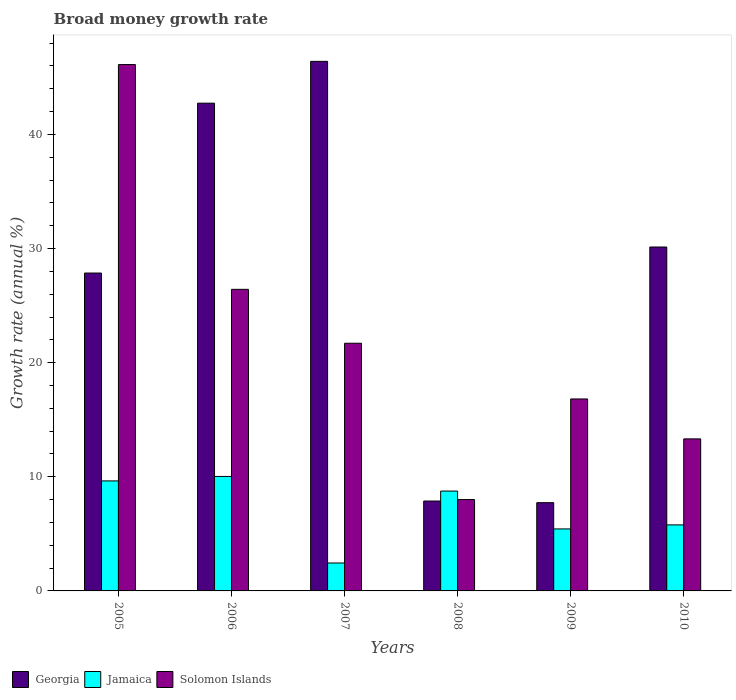Are the number of bars on each tick of the X-axis equal?
Provide a succinct answer. Yes. What is the label of the 5th group of bars from the left?
Your answer should be compact. 2009. In how many cases, is the number of bars for a given year not equal to the number of legend labels?
Provide a succinct answer. 0. What is the growth rate in Solomon Islands in 2006?
Give a very brief answer. 26.42. Across all years, what is the maximum growth rate in Georgia?
Offer a very short reply. 46.4. Across all years, what is the minimum growth rate in Georgia?
Keep it short and to the point. 7.73. In which year was the growth rate in Solomon Islands minimum?
Your answer should be compact. 2008. What is the total growth rate in Jamaica in the graph?
Your answer should be compact. 42.08. What is the difference between the growth rate in Georgia in 2007 and that in 2010?
Your response must be concise. 16.27. What is the difference between the growth rate in Solomon Islands in 2008 and the growth rate in Georgia in 2007?
Your response must be concise. -38.39. What is the average growth rate in Georgia per year?
Make the answer very short. 27.12. In the year 2006, what is the difference between the growth rate in Jamaica and growth rate in Georgia?
Your answer should be compact. -32.71. What is the ratio of the growth rate in Solomon Islands in 2009 to that in 2010?
Offer a terse response. 1.26. Is the difference between the growth rate in Jamaica in 2006 and 2010 greater than the difference between the growth rate in Georgia in 2006 and 2010?
Your response must be concise. No. What is the difference between the highest and the second highest growth rate in Solomon Islands?
Provide a succinct answer. 19.69. What is the difference between the highest and the lowest growth rate in Georgia?
Your answer should be very brief. 38.67. What does the 3rd bar from the left in 2006 represents?
Your answer should be very brief. Solomon Islands. What does the 2nd bar from the right in 2008 represents?
Your response must be concise. Jamaica. Is it the case that in every year, the sum of the growth rate in Georgia and growth rate in Solomon Islands is greater than the growth rate in Jamaica?
Your answer should be compact. Yes. Are the values on the major ticks of Y-axis written in scientific E-notation?
Ensure brevity in your answer.  No. Does the graph contain any zero values?
Offer a terse response. No. Does the graph contain grids?
Ensure brevity in your answer.  No. Where does the legend appear in the graph?
Make the answer very short. Bottom left. How many legend labels are there?
Your answer should be compact. 3. How are the legend labels stacked?
Keep it short and to the point. Horizontal. What is the title of the graph?
Offer a terse response. Broad money growth rate. What is the label or title of the X-axis?
Offer a very short reply. Years. What is the label or title of the Y-axis?
Provide a succinct answer. Growth rate (annual %). What is the Growth rate (annual %) of Georgia in 2005?
Ensure brevity in your answer.  27.85. What is the Growth rate (annual %) in Jamaica in 2005?
Provide a succinct answer. 9.64. What is the Growth rate (annual %) of Solomon Islands in 2005?
Keep it short and to the point. 46.12. What is the Growth rate (annual %) of Georgia in 2006?
Offer a terse response. 42.74. What is the Growth rate (annual %) of Jamaica in 2006?
Give a very brief answer. 10.03. What is the Growth rate (annual %) of Solomon Islands in 2006?
Provide a short and direct response. 26.42. What is the Growth rate (annual %) in Georgia in 2007?
Your answer should be compact. 46.4. What is the Growth rate (annual %) of Jamaica in 2007?
Keep it short and to the point. 2.45. What is the Growth rate (annual %) of Solomon Islands in 2007?
Your response must be concise. 21.7. What is the Growth rate (annual %) of Georgia in 2008?
Ensure brevity in your answer.  7.88. What is the Growth rate (annual %) of Jamaica in 2008?
Your answer should be compact. 8.75. What is the Growth rate (annual %) of Solomon Islands in 2008?
Ensure brevity in your answer.  8.01. What is the Growth rate (annual %) in Georgia in 2009?
Offer a terse response. 7.73. What is the Growth rate (annual %) in Jamaica in 2009?
Provide a succinct answer. 5.43. What is the Growth rate (annual %) of Solomon Islands in 2009?
Provide a succinct answer. 16.82. What is the Growth rate (annual %) in Georgia in 2010?
Ensure brevity in your answer.  30.13. What is the Growth rate (annual %) of Jamaica in 2010?
Keep it short and to the point. 5.79. What is the Growth rate (annual %) in Solomon Islands in 2010?
Keep it short and to the point. 13.32. Across all years, what is the maximum Growth rate (annual %) of Georgia?
Offer a terse response. 46.4. Across all years, what is the maximum Growth rate (annual %) of Jamaica?
Your answer should be very brief. 10.03. Across all years, what is the maximum Growth rate (annual %) in Solomon Islands?
Your response must be concise. 46.12. Across all years, what is the minimum Growth rate (annual %) of Georgia?
Ensure brevity in your answer.  7.73. Across all years, what is the minimum Growth rate (annual %) of Jamaica?
Offer a very short reply. 2.45. Across all years, what is the minimum Growth rate (annual %) in Solomon Islands?
Offer a very short reply. 8.01. What is the total Growth rate (annual %) of Georgia in the graph?
Keep it short and to the point. 162.73. What is the total Growth rate (annual %) of Jamaica in the graph?
Your response must be concise. 42.08. What is the total Growth rate (annual %) of Solomon Islands in the graph?
Offer a terse response. 132.39. What is the difference between the Growth rate (annual %) of Georgia in 2005 and that in 2006?
Ensure brevity in your answer.  -14.88. What is the difference between the Growth rate (annual %) in Jamaica in 2005 and that in 2006?
Offer a very short reply. -0.39. What is the difference between the Growth rate (annual %) in Solomon Islands in 2005 and that in 2006?
Offer a terse response. 19.69. What is the difference between the Growth rate (annual %) of Georgia in 2005 and that in 2007?
Offer a terse response. -18.55. What is the difference between the Growth rate (annual %) of Jamaica in 2005 and that in 2007?
Your response must be concise. 7.19. What is the difference between the Growth rate (annual %) in Solomon Islands in 2005 and that in 2007?
Your answer should be compact. 24.42. What is the difference between the Growth rate (annual %) of Georgia in 2005 and that in 2008?
Your response must be concise. 19.97. What is the difference between the Growth rate (annual %) in Jamaica in 2005 and that in 2008?
Give a very brief answer. 0.89. What is the difference between the Growth rate (annual %) in Solomon Islands in 2005 and that in 2008?
Offer a very short reply. 38.11. What is the difference between the Growth rate (annual %) in Georgia in 2005 and that in 2009?
Your answer should be very brief. 20.12. What is the difference between the Growth rate (annual %) of Jamaica in 2005 and that in 2009?
Your answer should be very brief. 4.21. What is the difference between the Growth rate (annual %) of Solomon Islands in 2005 and that in 2009?
Offer a very short reply. 29.3. What is the difference between the Growth rate (annual %) of Georgia in 2005 and that in 2010?
Provide a succinct answer. -2.28. What is the difference between the Growth rate (annual %) of Jamaica in 2005 and that in 2010?
Your answer should be very brief. 3.85. What is the difference between the Growth rate (annual %) of Solomon Islands in 2005 and that in 2010?
Offer a very short reply. 32.8. What is the difference between the Growth rate (annual %) in Georgia in 2006 and that in 2007?
Keep it short and to the point. -3.66. What is the difference between the Growth rate (annual %) in Jamaica in 2006 and that in 2007?
Provide a succinct answer. 7.58. What is the difference between the Growth rate (annual %) in Solomon Islands in 2006 and that in 2007?
Offer a very short reply. 4.72. What is the difference between the Growth rate (annual %) in Georgia in 2006 and that in 2008?
Give a very brief answer. 34.86. What is the difference between the Growth rate (annual %) in Jamaica in 2006 and that in 2008?
Offer a very short reply. 1.28. What is the difference between the Growth rate (annual %) of Solomon Islands in 2006 and that in 2008?
Offer a terse response. 18.42. What is the difference between the Growth rate (annual %) in Georgia in 2006 and that in 2009?
Give a very brief answer. 35. What is the difference between the Growth rate (annual %) in Jamaica in 2006 and that in 2009?
Make the answer very short. 4.6. What is the difference between the Growth rate (annual %) of Solomon Islands in 2006 and that in 2009?
Your response must be concise. 9.6. What is the difference between the Growth rate (annual %) in Georgia in 2006 and that in 2010?
Your answer should be compact. 12.6. What is the difference between the Growth rate (annual %) of Jamaica in 2006 and that in 2010?
Give a very brief answer. 4.24. What is the difference between the Growth rate (annual %) in Solomon Islands in 2006 and that in 2010?
Provide a succinct answer. 13.1. What is the difference between the Growth rate (annual %) in Georgia in 2007 and that in 2008?
Provide a succinct answer. 38.52. What is the difference between the Growth rate (annual %) of Jamaica in 2007 and that in 2008?
Make the answer very short. -6.3. What is the difference between the Growth rate (annual %) of Solomon Islands in 2007 and that in 2008?
Make the answer very short. 13.7. What is the difference between the Growth rate (annual %) in Georgia in 2007 and that in 2009?
Offer a terse response. 38.67. What is the difference between the Growth rate (annual %) in Jamaica in 2007 and that in 2009?
Provide a short and direct response. -2.98. What is the difference between the Growth rate (annual %) in Solomon Islands in 2007 and that in 2009?
Provide a short and direct response. 4.88. What is the difference between the Growth rate (annual %) of Georgia in 2007 and that in 2010?
Provide a short and direct response. 16.27. What is the difference between the Growth rate (annual %) in Jamaica in 2007 and that in 2010?
Provide a succinct answer. -3.34. What is the difference between the Growth rate (annual %) in Solomon Islands in 2007 and that in 2010?
Make the answer very short. 8.38. What is the difference between the Growth rate (annual %) of Georgia in 2008 and that in 2009?
Give a very brief answer. 0.14. What is the difference between the Growth rate (annual %) in Jamaica in 2008 and that in 2009?
Offer a very short reply. 3.32. What is the difference between the Growth rate (annual %) in Solomon Islands in 2008 and that in 2009?
Ensure brevity in your answer.  -8.81. What is the difference between the Growth rate (annual %) in Georgia in 2008 and that in 2010?
Provide a succinct answer. -22.26. What is the difference between the Growth rate (annual %) of Jamaica in 2008 and that in 2010?
Ensure brevity in your answer.  2.96. What is the difference between the Growth rate (annual %) in Solomon Islands in 2008 and that in 2010?
Ensure brevity in your answer.  -5.32. What is the difference between the Growth rate (annual %) in Georgia in 2009 and that in 2010?
Ensure brevity in your answer.  -22.4. What is the difference between the Growth rate (annual %) of Jamaica in 2009 and that in 2010?
Provide a short and direct response. -0.35. What is the difference between the Growth rate (annual %) of Solomon Islands in 2009 and that in 2010?
Provide a short and direct response. 3.5. What is the difference between the Growth rate (annual %) of Georgia in 2005 and the Growth rate (annual %) of Jamaica in 2006?
Offer a very short reply. 17.82. What is the difference between the Growth rate (annual %) of Georgia in 2005 and the Growth rate (annual %) of Solomon Islands in 2006?
Keep it short and to the point. 1.43. What is the difference between the Growth rate (annual %) of Jamaica in 2005 and the Growth rate (annual %) of Solomon Islands in 2006?
Provide a short and direct response. -16.79. What is the difference between the Growth rate (annual %) of Georgia in 2005 and the Growth rate (annual %) of Jamaica in 2007?
Offer a terse response. 25.4. What is the difference between the Growth rate (annual %) of Georgia in 2005 and the Growth rate (annual %) of Solomon Islands in 2007?
Your answer should be very brief. 6.15. What is the difference between the Growth rate (annual %) of Jamaica in 2005 and the Growth rate (annual %) of Solomon Islands in 2007?
Make the answer very short. -12.06. What is the difference between the Growth rate (annual %) in Georgia in 2005 and the Growth rate (annual %) in Jamaica in 2008?
Make the answer very short. 19.1. What is the difference between the Growth rate (annual %) in Georgia in 2005 and the Growth rate (annual %) in Solomon Islands in 2008?
Provide a short and direct response. 19.85. What is the difference between the Growth rate (annual %) in Jamaica in 2005 and the Growth rate (annual %) in Solomon Islands in 2008?
Your response must be concise. 1.63. What is the difference between the Growth rate (annual %) in Georgia in 2005 and the Growth rate (annual %) in Jamaica in 2009?
Provide a short and direct response. 22.42. What is the difference between the Growth rate (annual %) of Georgia in 2005 and the Growth rate (annual %) of Solomon Islands in 2009?
Provide a short and direct response. 11.03. What is the difference between the Growth rate (annual %) of Jamaica in 2005 and the Growth rate (annual %) of Solomon Islands in 2009?
Your answer should be very brief. -7.18. What is the difference between the Growth rate (annual %) in Georgia in 2005 and the Growth rate (annual %) in Jamaica in 2010?
Your response must be concise. 22.07. What is the difference between the Growth rate (annual %) of Georgia in 2005 and the Growth rate (annual %) of Solomon Islands in 2010?
Your answer should be very brief. 14.53. What is the difference between the Growth rate (annual %) in Jamaica in 2005 and the Growth rate (annual %) in Solomon Islands in 2010?
Keep it short and to the point. -3.68. What is the difference between the Growth rate (annual %) in Georgia in 2006 and the Growth rate (annual %) in Jamaica in 2007?
Your answer should be very brief. 40.29. What is the difference between the Growth rate (annual %) of Georgia in 2006 and the Growth rate (annual %) of Solomon Islands in 2007?
Offer a very short reply. 21.04. What is the difference between the Growth rate (annual %) of Jamaica in 2006 and the Growth rate (annual %) of Solomon Islands in 2007?
Offer a very short reply. -11.67. What is the difference between the Growth rate (annual %) of Georgia in 2006 and the Growth rate (annual %) of Jamaica in 2008?
Ensure brevity in your answer.  33.99. What is the difference between the Growth rate (annual %) in Georgia in 2006 and the Growth rate (annual %) in Solomon Islands in 2008?
Offer a very short reply. 34.73. What is the difference between the Growth rate (annual %) in Jamaica in 2006 and the Growth rate (annual %) in Solomon Islands in 2008?
Keep it short and to the point. 2.02. What is the difference between the Growth rate (annual %) in Georgia in 2006 and the Growth rate (annual %) in Jamaica in 2009?
Offer a terse response. 37.3. What is the difference between the Growth rate (annual %) of Georgia in 2006 and the Growth rate (annual %) of Solomon Islands in 2009?
Make the answer very short. 25.92. What is the difference between the Growth rate (annual %) in Jamaica in 2006 and the Growth rate (annual %) in Solomon Islands in 2009?
Offer a very short reply. -6.79. What is the difference between the Growth rate (annual %) of Georgia in 2006 and the Growth rate (annual %) of Jamaica in 2010?
Your answer should be very brief. 36.95. What is the difference between the Growth rate (annual %) of Georgia in 2006 and the Growth rate (annual %) of Solomon Islands in 2010?
Keep it short and to the point. 29.42. What is the difference between the Growth rate (annual %) of Jamaica in 2006 and the Growth rate (annual %) of Solomon Islands in 2010?
Your answer should be compact. -3.29. What is the difference between the Growth rate (annual %) of Georgia in 2007 and the Growth rate (annual %) of Jamaica in 2008?
Your answer should be very brief. 37.65. What is the difference between the Growth rate (annual %) in Georgia in 2007 and the Growth rate (annual %) in Solomon Islands in 2008?
Your answer should be very brief. 38.39. What is the difference between the Growth rate (annual %) of Jamaica in 2007 and the Growth rate (annual %) of Solomon Islands in 2008?
Give a very brief answer. -5.56. What is the difference between the Growth rate (annual %) of Georgia in 2007 and the Growth rate (annual %) of Jamaica in 2009?
Provide a short and direct response. 40.97. What is the difference between the Growth rate (annual %) in Georgia in 2007 and the Growth rate (annual %) in Solomon Islands in 2009?
Offer a very short reply. 29.58. What is the difference between the Growth rate (annual %) in Jamaica in 2007 and the Growth rate (annual %) in Solomon Islands in 2009?
Your answer should be very brief. -14.37. What is the difference between the Growth rate (annual %) of Georgia in 2007 and the Growth rate (annual %) of Jamaica in 2010?
Your response must be concise. 40.61. What is the difference between the Growth rate (annual %) of Georgia in 2007 and the Growth rate (annual %) of Solomon Islands in 2010?
Ensure brevity in your answer.  33.08. What is the difference between the Growth rate (annual %) of Jamaica in 2007 and the Growth rate (annual %) of Solomon Islands in 2010?
Ensure brevity in your answer.  -10.87. What is the difference between the Growth rate (annual %) in Georgia in 2008 and the Growth rate (annual %) in Jamaica in 2009?
Your answer should be very brief. 2.44. What is the difference between the Growth rate (annual %) in Georgia in 2008 and the Growth rate (annual %) in Solomon Islands in 2009?
Your answer should be compact. -8.94. What is the difference between the Growth rate (annual %) of Jamaica in 2008 and the Growth rate (annual %) of Solomon Islands in 2009?
Keep it short and to the point. -8.07. What is the difference between the Growth rate (annual %) in Georgia in 2008 and the Growth rate (annual %) in Jamaica in 2010?
Give a very brief answer. 2.09. What is the difference between the Growth rate (annual %) of Georgia in 2008 and the Growth rate (annual %) of Solomon Islands in 2010?
Your answer should be compact. -5.44. What is the difference between the Growth rate (annual %) in Jamaica in 2008 and the Growth rate (annual %) in Solomon Islands in 2010?
Your response must be concise. -4.57. What is the difference between the Growth rate (annual %) of Georgia in 2009 and the Growth rate (annual %) of Jamaica in 2010?
Provide a short and direct response. 1.95. What is the difference between the Growth rate (annual %) in Georgia in 2009 and the Growth rate (annual %) in Solomon Islands in 2010?
Offer a terse response. -5.59. What is the difference between the Growth rate (annual %) of Jamaica in 2009 and the Growth rate (annual %) of Solomon Islands in 2010?
Provide a succinct answer. -7.89. What is the average Growth rate (annual %) of Georgia per year?
Keep it short and to the point. 27.12. What is the average Growth rate (annual %) in Jamaica per year?
Provide a short and direct response. 7.01. What is the average Growth rate (annual %) in Solomon Islands per year?
Your answer should be compact. 22.06. In the year 2005, what is the difference between the Growth rate (annual %) of Georgia and Growth rate (annual %) of Jamaica?
Offer a terse response. 18.21. In the year 2005, what is the difference between the Growth rate (annual %) in Georgia and Growth rate (annual %) in Solomon Islands?
Your answer should be compact. -18.27. In the year 2005, what is the difference between the Growth rate (annual %) in Jamaica and Growth rate (annual %) in Solomon Islands?
Make the answer very short. -36.48. In the year 2006, what is the difference between the Growth rate (annual %) of Georgia and Growth rate (annual %) of Jamaica?
Your answer should be compact. 32.71. In the year 2006, what is the difference between the Growth rate (annual %) of Georgia and Growth rate (annual %) of Solomon Islands?
Ensure brevity in your answer.  16.31. In the year 2006, what is the difference between the Growth rate (annual %) of Jamaica and Growth rate (annual %) of Solomon Islands?
Offer a terse response. -16.39. In the year 2007, what is the difference between the Growth rate (annual %) of Georgia and Growth rate (annual %) of Jamaica?
Your response must be concise. 43.95. In the year 2007, what is the difference between the Growth rate (annual %) of Georgia and Growth rate (annual %) of Solomon Islands?
Give a very brief answer. 24.7. In the year 2007, what is the difference between the Growth rate (annual %) in Jamaica and Growth rate (annual %) in Solomon Islands?
Provide a succinct answer. -19.25. In the year 2008, what is the difference between the Growth rate (annual %) in Georgia and Growth rate (annual %) in Jamaica?
Provide a succinct answer. -0.87. In the year 2008, what is the difference between the Growth rate (annual %) of Georgia and Growth rate (annual %) of Solomon Islands?
Your answer should be very brief. -0.13. In the year 2008, what is the difference between the Growth rate (annual %) of Jamaica and Growth rate (annual %) of Solomon Islands?
Your response must be concise. 0.74. In the year 2009, what is the difference between the Growth rate (annual %) in Georgia and Growth rate (annual %) in Jamaica?
Offer a terse response. 2.3. In the year 2009, what is the difference between the Growth rate (annual %) of Georgia and Growth rate (annual %) of Solomon Islands?
Provide a succinct answer. -9.09. In the year 2009, what is the difference between the Growth rate (annual %) in Jamaica and Growth rate (annual %) in Solomon Islands?
Provide a short and direct response. -11.39. In the year 2010, what is the difference between the Growth rate (annual %) in Georgia and Growth rate (annual %) in Jamaica?
Offer a terse response. 24.35. In the year 2010, what is the difference between the Growth rate (annual %) of Georgia and Growth rate (annual %) of Solomon Islands?
Offer a terse response. 16.81. In the year 2010, what is the difference between the Growth rate (annual %) in Jamaica and Growth rate (annual %) in Solomon Islands?
Provide a succinct answer. -7.54. What is the ratio of the Growth rate (annual %) in Georgia in 2005 to that in 2006?
Provide a succinct answer. 0.65. What is the ratio of the Growth rate (annual %) in Jamaica in 2005 to that in 2006?
Offer a terse response. 0.96. What is the ratio of the Growth rate (annual %) of Solomon Islands in 2005 to that in 2006?
Keep it short and to the point. 1.75. What is the ratio of the Growth rate (annual %) of Georgia in 2005 to that in 2007?
Keep it short and to the point. 0.6. What is the ratio of the Growth rate (annual %) of Jamaica in 2005 to that in 2007?
Provide a succinct answer. 3.94. What is the ratio of the Growth rate (annual %) of Solomon Islands in 2005 to that in 2007?
Your answer should be compact. 2.13. What is the ratio of the Growth rate (annual %) of Georgia in 2005 to that in 2008?
Your answer should be very brief. 3.54. What is the ratio of the Growth rate (annual %) of Jamaica in 2005 to that in 2008?
Give a very brief answer. 1.1. What is the ratio of the Growth rate (annual %) of Solomon Islands in 2005 to that in 2008?
Provide a short and direct response. 5.76. What is the ratio of the Growth rate (annual %) in Georgia in 2005 to that in 2009?
Your answer should be compact. 3.6. What is the ratio of the Growth rate (annual %) in Jamaica in 2005 to that in 2009?
Your answer should be very brief. 1.77. What is the ratio of the Growth rate (annual %) in Solomon Islands in 2005 to that in 2009?
Your answer should be compact. 2.74. What is the ratio of the Growth rate (annual %) in Georgia in 2005 to that in 2010?
Provide a short and direct response. 0.92. What is the ratio of the Growth rate (annual %) in Jamaica in 2005 to that in 2010?
Keep it short and to the point. 1.67. What is the ratio of the Growth rate (annual %) in Solomon Islands in 2005 to that in 2010?
Ensure brevity in your answer.  3.46. What is the ratio of the Growth rate (annual %) in Georgia in 2006 to that in 2007?
Your response must be concise. 0.92. What is the ratio of the Growth rate (annual %) of Jamaica in 2006 to that in 2007?
Offer a terse response. 4.1. What is the ratio of the Growth rate (annual %) of Solomon Islands in 2006 to that in 2007?
Give a very brief answer. 1.22. What is the ratio of the Growth rate (annual %) in Georgia in 2006 to that in 2008?
Offer a very short reply. 5.43. What is the ratio of the Growth rate (annual %) of Jamaica in 2006 to that in 2008?
Offer a very short reply. 1.15. What is the ratio of the Growth rate (annual %) in Solomon Islands in 2006 to that in 2008?
Your answer should be very brief. 3.3. What is the ratio of the Growth rate (annual %) of Georgia in 2006 to that in 2009?
Give a very brief answer. 5.53. What is the ratio of the Growth rate (annual %) in Jamaica in 2006 to that in 2009?
Offer a very short reply. 1.85. What is the ratio of the Growth rate (annual %) in Solomon Islands in 2006 to that in 2009?
Your answer should be compact. 1.57. What is the ratio of the Growth rate (annual %) in Georgia in 2006 to that in 2010?
Provide a short and direct response. 1.42. What is the ratio of the Growth rate (annual %) in Jamaica in 2006 to that in 2010?
Offer a terse response. 1.73. What is the ratio of the Growth rate (annual %) in Solomon Islands in 2006 to that in 2010?
Your answer should be very brief. 1.98. What is the ratio of the Growth rate (annual %) in Georgia in 2007 to that in 2008?
Offer a terse response. 5.89. What is the ratio of the Growth rate (annual %) of Jamaica in 2007 to that in 2008?
Keep it short and to the point. 0.28. What is the ratio of the Growth rate (annual %) in Solomon Islands in 2007 to that in 2008?
Keep it short and to the point. 2.71. What is the ratio of the Growth rate (annual %) of Georgia in 2007 to that in 2009?
Make the answer very short. 6. What is the ratio of the Growth rate (annual %) of Jamaica in 2007 to that in 2009?
Offer a very short reply. 0.45. What is the ratio of the Growth rate (annual %) of Solomon Islands in 2007 to that in 2009?
Offer a very short reply. 1.29. What is the ratio of the Growth rate (annual %) in Georgia in 2007 to that in 2010?
Provide a short and direct response. 1.54. What is the ratio of the Growth rate (annual %) of Jamaica in 2007 to that in 2010?
Offer a terse response. 0.42. What is the ratio of the Growth rate (annual %) in Solomon Islands in 2007 to that in 2010?
Provide a short and direct response. 1.63. What is the ratio of the Growth rate (annual %) in Georgia in 2008 to that in 2009?
Offer a terse response. 1.02. What is the ratio of the Growth rate (annual %) in Jamaica in 2008 to that in 2009?
Offer a very short reply. 1.61. What is the ratio of the Growth rate (annual %) of Solomon Islands in 2008 to that in 2009?
Your answer should be very brief. 0.48. What is the ratio of the Growth rate (annual %) in Georgia in 2008 to that in 2010?
Give a very brief answer. 0.26. What is the ratio of the Growth rate (annual %) in Jamaica in 2008 to that in 2010?
Provide a succinct answer. 1.51. What is the ratio of the Growth rate (annual %) of Solomon Islands in 2008 to that in 2010?
Give a very brief answer. 0.6. What is the ratio of the Growth rate (annual %) in Georgia in 2009 to that in 2010?
Provide a short and direct response. 0.26. What is the ratio of the Growth rate (annual %) of Jamaica in 2009 to that in 2010?
Give a very brief answer. 0.94. What is the ratio of the Growth rate (annual %) of Solomon Islands in 2009 to that in 2010?
Your answer should be very brief. 1.26. What is the difference between the highest and the second highest Growth rate (annual %) in Georgia?
Give a very brief answer. 3.66. What is the difference between the highest and the second highest Growth rate (annual %) of Jamaica?
Keep it short and to the point. 0.39. What is the difference between the highest and the second highest Growth rate (annual %) in Solomon Islands?
Provide a short and direct response. 19.69. What is the difference between the highest and the lowest Growth rate (annual %) in Georgia?
Offer a very short reply. 38.67. What is the difference between the highest and the lowest Growth rate (annual %) of Jamaica?
Provide a succinct answer. 7.58. What is the difference between the highest and the lowest Growth rate (annual %) of Solomon Islands?
Give a very brief answer. 38.11. 